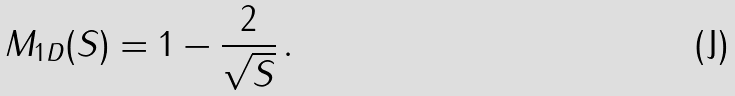<formula> <loc_0><loc_0><loc_500><loc_500>M _ { 1 D } ( S ) = 1 - \frac { 2 } { \sqrt { S } } \, .</formula> 